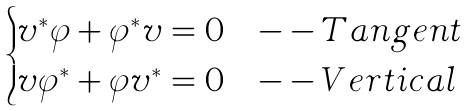<formula> <loc_0><loc_0><loc_500><loc_500>\begin{cases} v ^ { * } \varphi + \varphi ^ { * } v = 0 & - - T a n g e n t \\ v \varphi ^ { * } + \varphi v ^ { * } = 0 & - - V e r t i c a l \end{cases}</formula> 